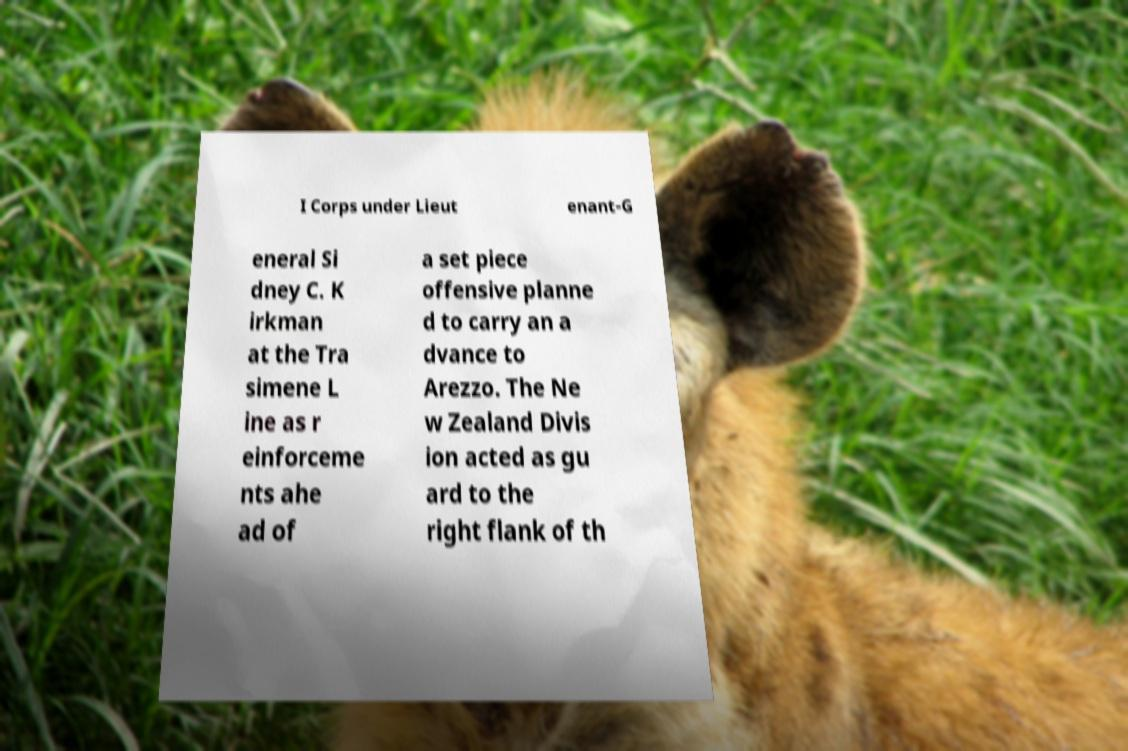For documentation purposes, I need the text within this image transcribed. Could you provide that? I Corps under Lieut enant-G eneral Si dney C. K irkman at the Tra simene L ine as r einforceme nts ahe ad of a set piece offensive planne d to carry an a dvance to Arezzo. The Ne w Zealand Divis ion acted as gu ard to the right flank of th 